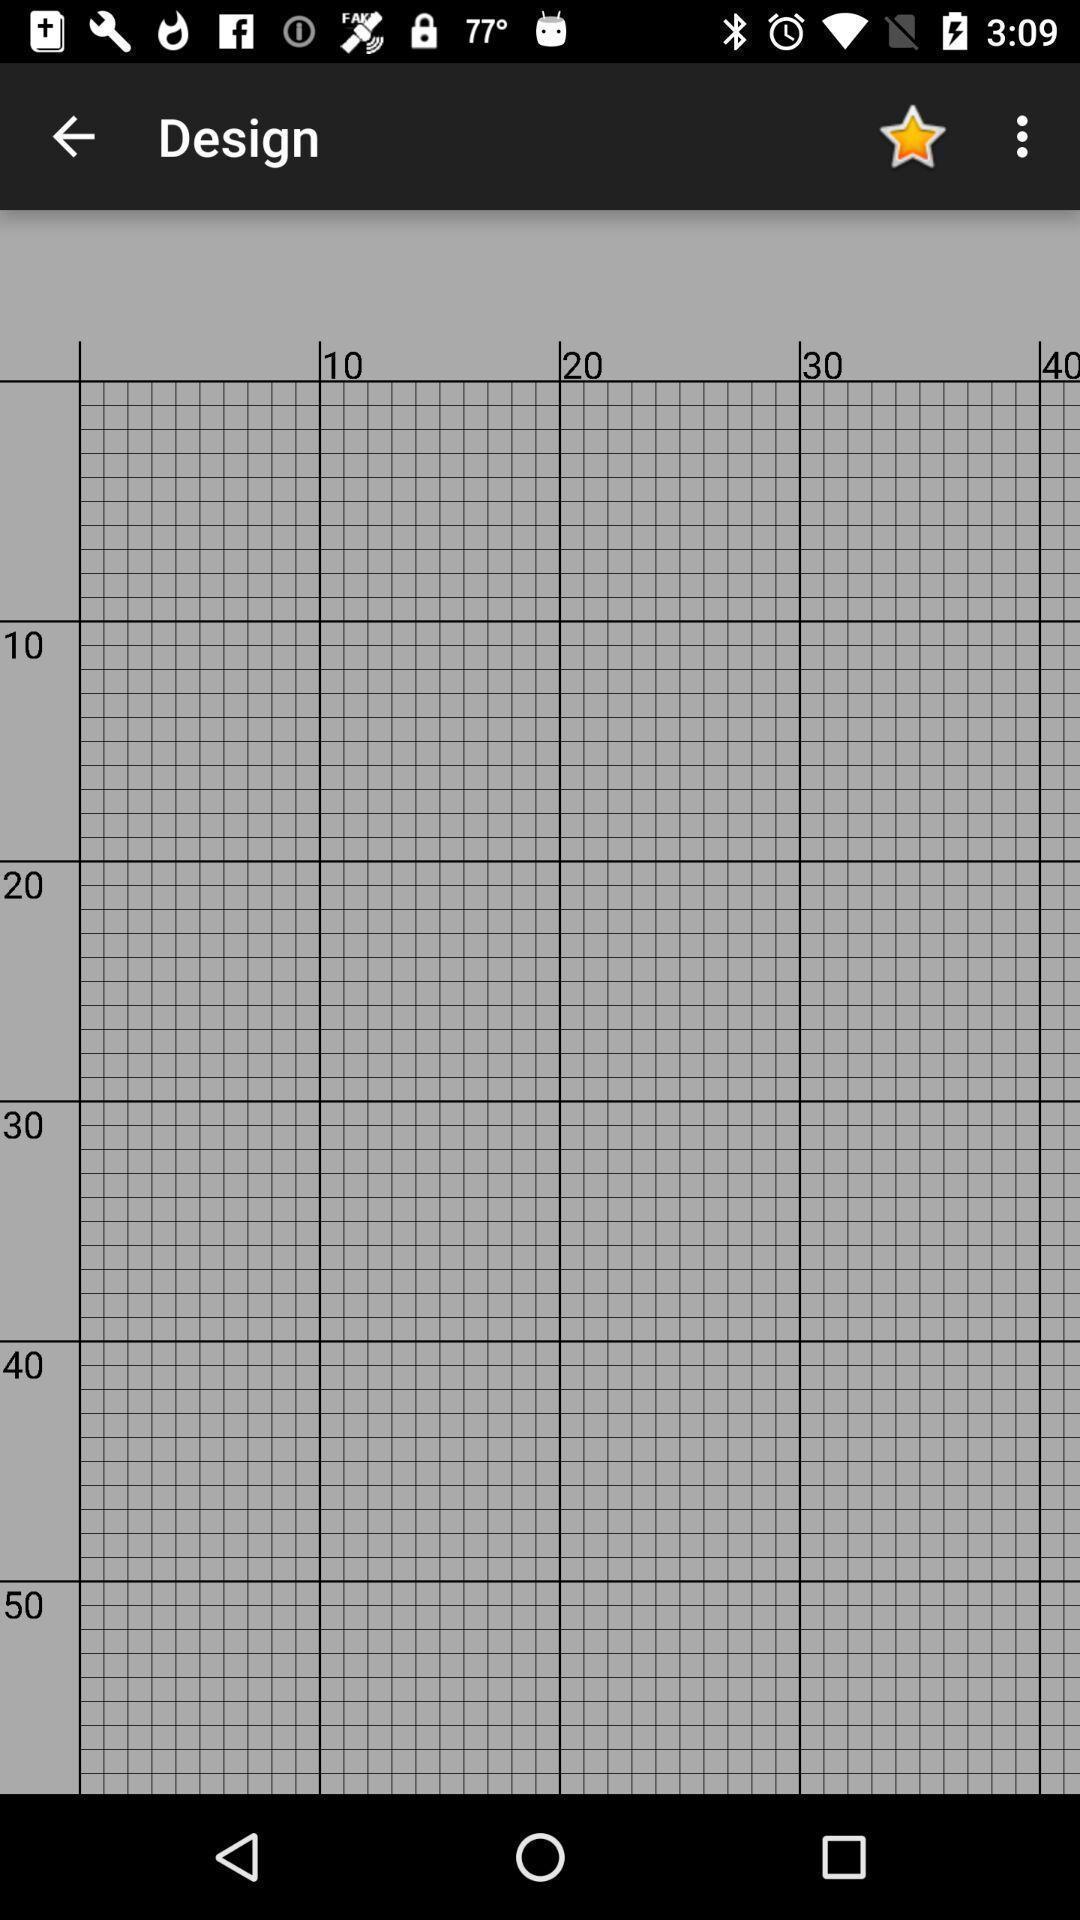What can you discern from this picture? Page displaying grids. 